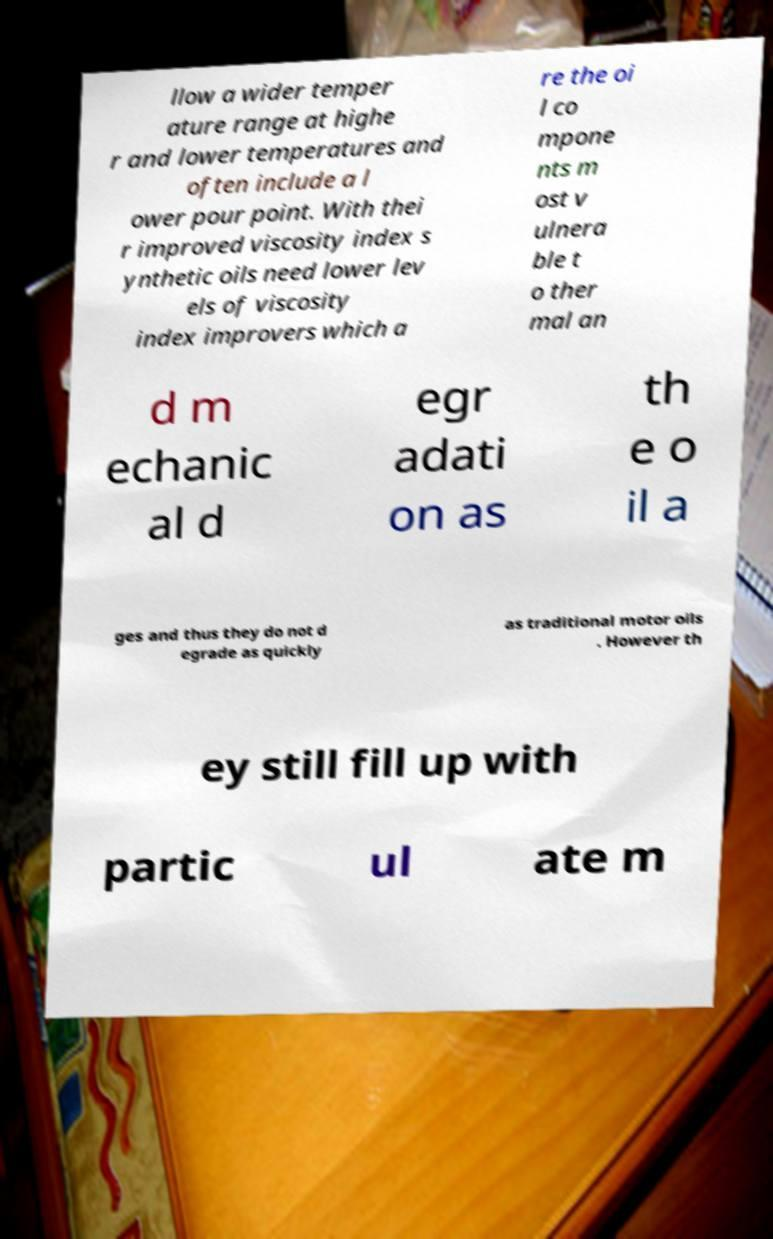Can you read and provide the text displayed in the image?This photo seems to have some interesting text. Can you extract and type it out for me? llow a wider temper ature range at highe r and lower temperatures and often include a l ower pour point. With thei r improved viscosity index s ynthetic oils need lower lev els of viscosity index improvers which a re the oi l co mpone nts m ost v ulnera ble t o ther mal an d m echanic al d egr adati on as th e o il a ges and thus they do not d egrade as quickly as traditional motor oils . However th ey still fill up with partic ul ate m 